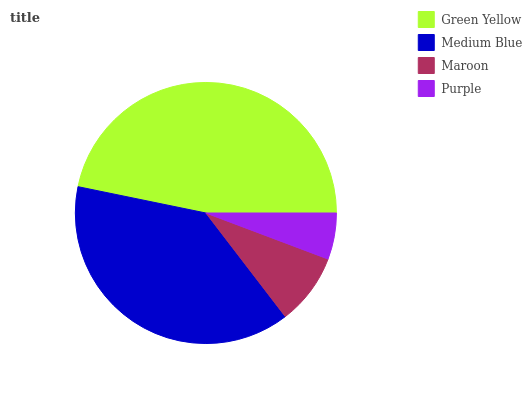Is Purple the minimum?
Answer yes or no. Yes. Is Green Yellow the maximum?
Answer yes or no. Yes. Is Medium Blue the minimum?
Answer yes or no. No. Is Medium Blue the maximum?
Answer yes or no. No. Is Green Yellow greater than Medium Blue?
Answer yes or no. Yes. Is Medium Blue less than Green Yellow?
Answer yes or no. Yes. Is Medium Blue greater than Green Yellow?
Answer yes or no. No. Is Green Yellow less than Medium Blue?
Answer yes or no. No. Is Medium Blue the high median?
Answer yes or no. Yes. Is Maroon the low median?
Answer yes or no. Yes. Is Green Yellow the high median?
Answer yes or no. No. Is Green Yellow the low median?
Answer yes or no. No. 